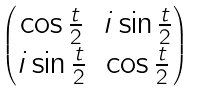Convert formula to latex. <formula><loc_0><loc_0><loc_500><loc_500>\begin{pmatrix} \cos \frac { t } { 2 } & i \sin \frac { t } { 2 } \\ i \sin \frac { t } { 2 } & \cos \frac { t } { 2 } \end{pmatrix}</formula> 